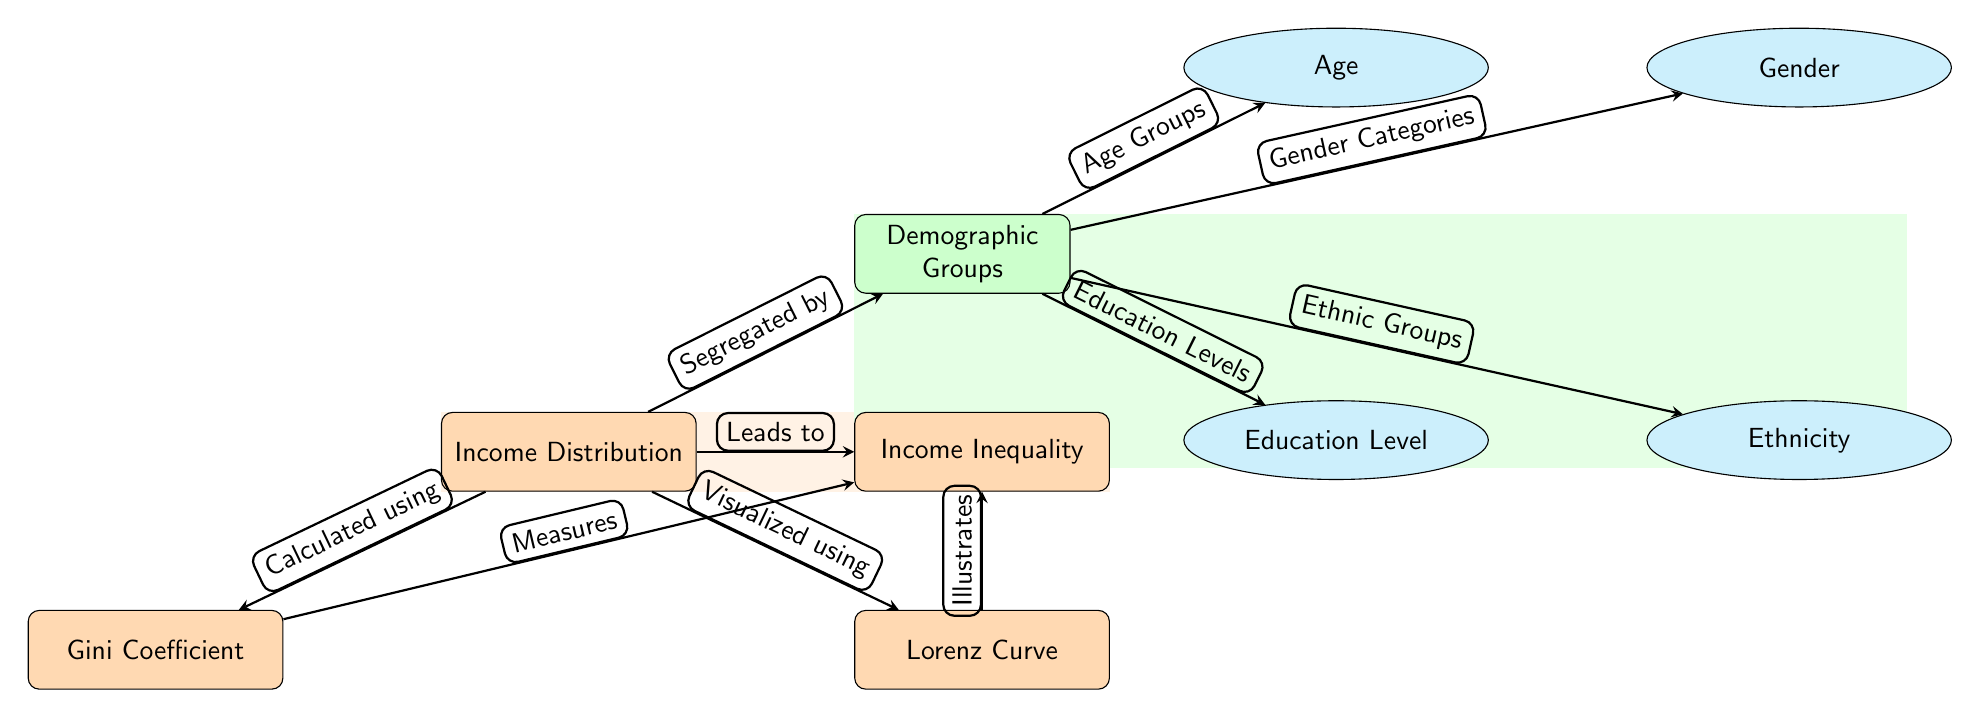What main concept does the diagram illustrate? The main concept illustrated in the diagram is "Income Distribution". This is the central node that connects to various other related components.
Answer: Income Distribution How many demographic groups are represented in the diagram? The diagram includes four demographic groups: Age, Gender, Education Level, and Ethnicity. These are sub-nodes branching from the main demographic node.
Answer: Four What does the Gini Coefficient measure? The Gini Coefficient measures "Income Inequality". This is indicated by the arrow that connects the Gini node to the inequality node, showing that it quantifies the degree of inequality in income distribution.
Answer: Income Inequality What does the Lorenz Curve illustrate? The Lorenz Curve illustrates "Income Inequality". The diagram specifies that the Lorenz Curve visually represents the distribution of income among the population.
Answer: Income Inequality Which demographic factor leads to the segregation of income distribution? The demographic groups node leads to the segregation of income distribution, indicating that different factors like age, gender, education, and ethnicity affect how income is distributed across the population.
Answer: Demographic Groups What does the orange background signify? The orange background signifies the area related to "Income Distribution". It visually highlights the primary theme of the diagram and encompasses relevant nodes and relationships.
Answer: Income Distribution What relationship connects the Lorenz Curve to the main theme of the diagram? The relationship shows that the Lorenz Curve is "Visualized using" the income distribution data, emphasizing its role in displaying the income distribution.
Answer: Visualized using Which node is calculated from income distribution? The Gini Coefficient node is calculated from the income distribution. This relationship is indicated in the diagram linking the income distribution to the Gini Coefficient.
Answer: Gini Coefficient Which demographic factors are directly categorized in the diagram? The demographic factors categorized in the diagram are Age, Gender, Education Level, and Ethnicity. Each of these is connected to the main demographic node.
Answer: Age, Gender, Education Level, Ethnicity 